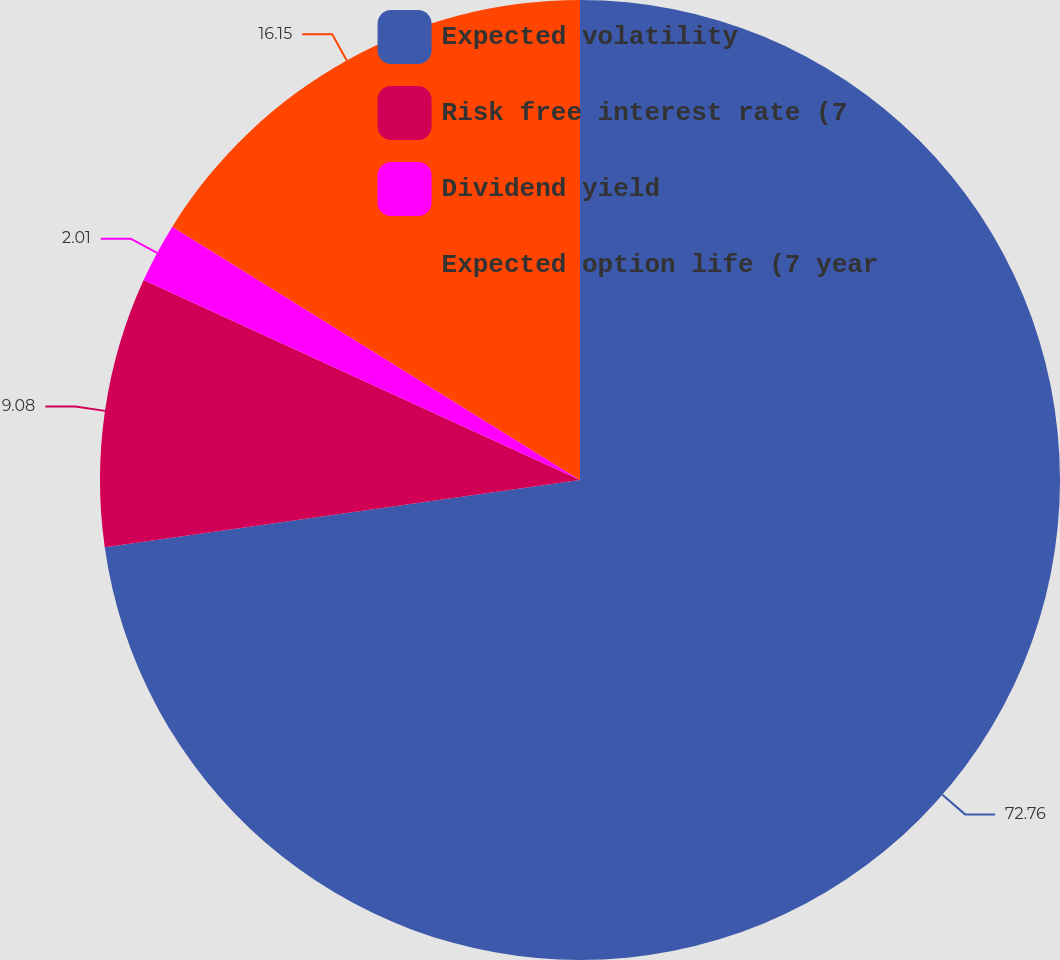<chart> <loc_0><loc_0><loc_500><loc_500><pie_chart><fcel>Expected volatility<fcel>Risk free interest rate (7<fcel>Dividend yield<fcel>Expected option life (7 year<nl><fcel>72.76%<fcel>9.08%<fcel>2.01%<fcel>16.15%<nl></chart> 